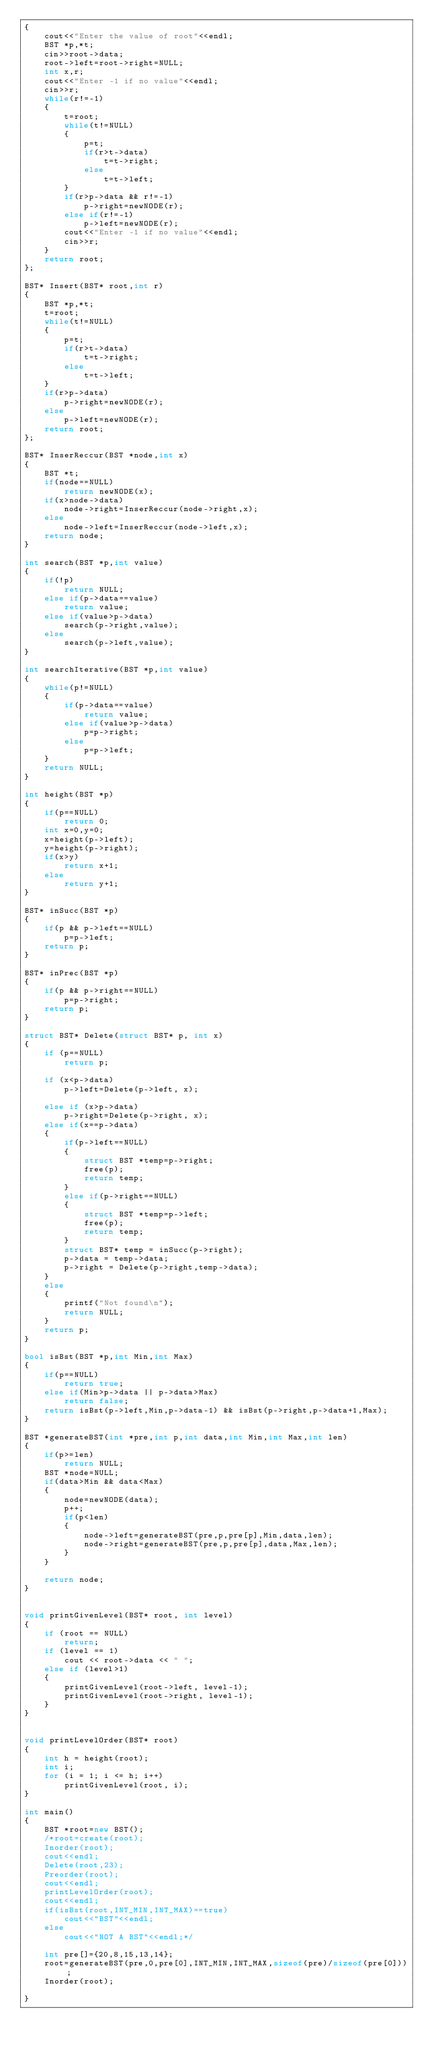<code> <loc_0><loc_0><loc_500><loc_500><_C++_>{
    cout<<"Enter the value of root"<<endl;
    BST *p,*t;
    cin>>root->data;
    root->left=root->right=NULL;
    int x,r;
    cout<<"Enter -1 if no value"<<endl;
    cin>>r;
    while(r!=-1)
    {
        t=root;
        while(t!=NULL)
        {
            p=t;
            if(r>t->data)
                t=t->right;
            else
                t=t->left;
        }
        if(r>p->data && r!=-1)
            p->right=newNODE(r);
        else if(r!=-1)
            p->left=newNODE(r);
        cout<<"Enter -1 if no value"<<endl;
        cin>>r;
    }
    return root;
};

BST* Insert(BST* root,int r)
{
    BST *p,*t;
    t=root;
    while(t!=NULL)
    {
        p=t;
        if(r>t->data)
            t=t->right;
        else
            t=t->left;
    }
    if(r>p->data)
        p->right=newNODE(r);
    else
        p->left=newNODE(r);
    return root;
};

BST* InserReccur(BST *node,int x)
{
    BST *t;
    if(node==NULL)
        return newNODE(x);
    if(x>node->data)
        node->right=InserReccur(node->right,x);
    else
        node->left=InserReccur(node->left,x);
    return node;
}

int search(BST *p,int value)
{
    if(!p)
        return NULL;
    else if(p->data==value)
        return value;
    else if(value>p->data)
        search(p->right,value);
    else
        search(p->left,value);
}

int searchIterative(BST *p,int value)
{
    while(p!=NULL)
    {
        if(p->data==value)
            return value;
        else if(value>p->data)
            p=p->right;
        else
            p=p->left;
    }
    return NULL;
}

int height(BST *p)
{
    if(p==NULL)
        return 0;
    int x=0,y=0;
    x=height(p->left);
    y=height(p->right);
    if(x>y)
        return x+1;
    else
        return y+1;
}

BST* inSucc(BST *p)
{
    if(p && p->left==NULL)
        p=p->left;
    return p;
}

BST* inPrec(BST *p)
{
    if(p && p->right==NULL)
        p=p->right;
    return p;
}

struct BST* Delete(struct BST* p, int x)
{
	if (p==NULL)
        return p;

	if (x<p->data)
		p->left=Delete(p->left, x);

	else if (x>p->data)
		p->right=Delete(p->right, x);
	else if(x==p->data)
	{
		if(p->left==NULL)
		{
			struct BST *temp=p->right;
			free(p);
			return temp;
		}
		else if(p->right==NULL)
		{
			struct BST *temp=p->left;
			free(p);
			return temp;
		}
		struct BST* temp = inSucc(p->right);
		p->data = temp->data;
		p->right = Delete(p->right,temp->data);
	}
	else
    {
        printf("Not found\n");
        return NULL;
    }
	return p;
}

bool isBst(BST *p,int Min,int Max)
{
    if(p==NULL)
        return true;
    else if(Min>p->data || p->data>Max)
        return false;
    return isBst(p->left,Min,p->data-1) && isBst(p->right,p->data+1,Max);
}

BST *generateBST(int *pre,int p,int data,int Min,int Max,int len)
{
    if(p>=len)
        return NULL;
    BST *node=NULL;
    if(data>Min && data<Max)
    {
        node=newNODE(data);
        p++;
        if(p<len)
        {
            node->left=generateBST(pre,p,pre[p],Min,data,len);
            node->right=generateBST(pre,p,pre[p],data,Max,len);
        }
    }

    return node;
}


void printGivenLevel(BST* root, int level)
{
    if (root == NULL)
        return;
    if (level == 1)
        cout << root->data << " ";
    else if (level>1)
    {
        printGivenLevel(root->left, level-1);
        printGivenLevel(root->right, level-1);
    }
}


void printLevelOrder(BST* root)
{
    int h = height(root);
    int i;
    for (i = 1; i <= h; i++)
        printGivenLevel(root, i);
}

int main()
{
    BST *root=new BST();
    /*root=create(root);
    Inorder(root);
    cout<<endl;
    Delete(root,23);
    Preorder(root);
    cout<<endl;
    printLevelOrder(root);
    cout<<endl;
    if(isBst(root,INT_MIN,INT_MAX)==true)
        cout<<"BST"<<endl;
    else
        cout<<"NOT A BST"<<endl;*/

    int pre[]={20,8,15,13,14};
    root=generateBST(pre,0,pre[0],INT_MIN,INT_MAX,sizeof(pre)/sizeof(pre[0]));
    Inorder(root);

}
</code> 